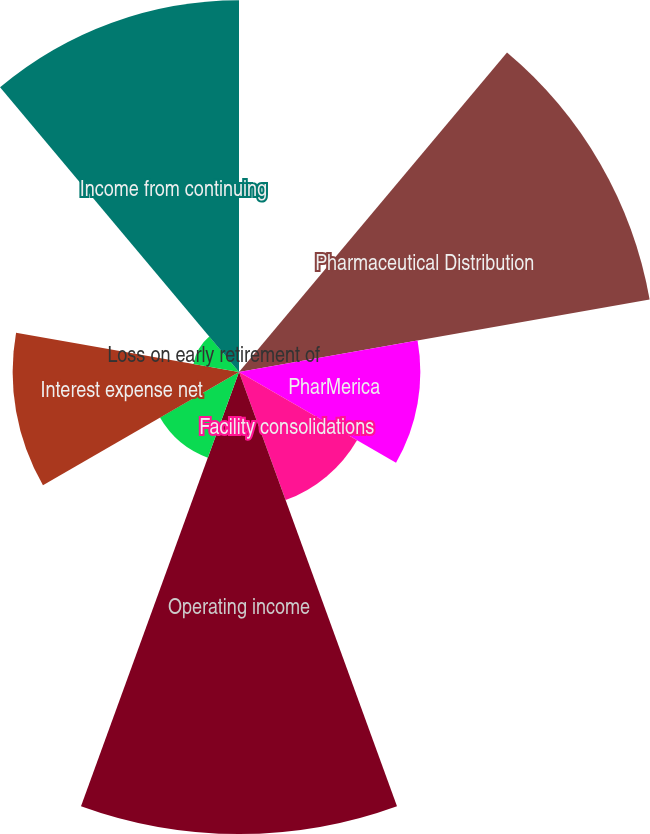Convert chart to OTSL. <chart><loc_0><loc_0><loc_500><loc_500><pie_chart><fcel>Fiscal year ended September 30<fcel>Pharmaceutical Distribution<fcel>PharMerica<fcel>Facility consolidations<fcel>Operating income<fcel>Other (income) loss<fcel>Interest expense net<fcel>Loss on early retirement of<fcel>Income from continuing<nl><fcel>0.05%<fcel>21.57%<fcel>9.38%<fcel>7.05%<fcel>23.9%<fcel>4.72%<fcel>11.71%<fcel>2.39%<fcel>19.23%<nl></chart> 